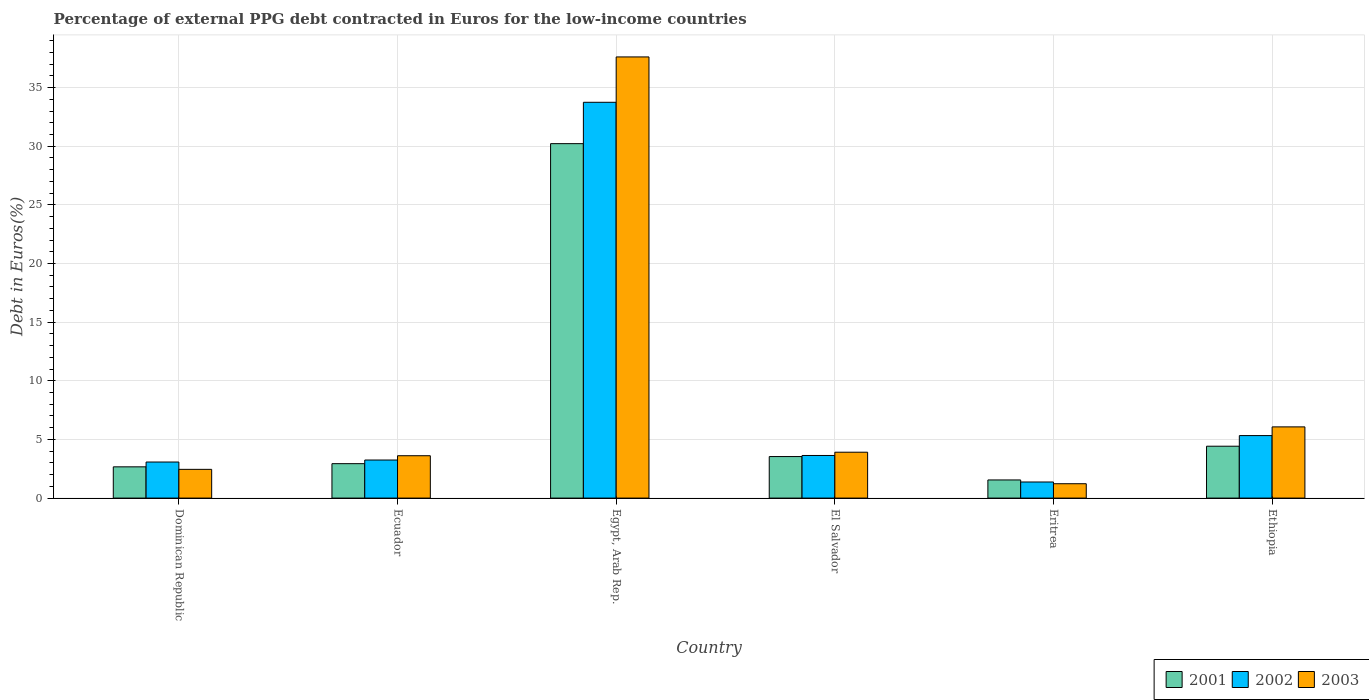How many different coloured bars are there?
Keep it short and to the point. 3. How many groups of bars are there?
Offer a very short reply. 6. Are the number of bars on each tick of the X-axis equal?
Give a very brief answer. Yes. What is the label of the 5th group of bars from the left?
Your answer should be very brief. Eritrea. In how many cases, is the number of bars for a given country not equal to the number of legend labels?
Your answer should be very brief. 0. What is the percentage of external PPG debt contracted in Euros in 2003 in Eritrea?
Your response must be concise. 1.23. Across all countries, what is the maximum percentage of external PPG debt contracted in Euros in 2003?
Ensure brevity in your answer.  37.61. Across all countries, what is the minimum percentage of external PPG debt contracted in Euros in 2003?
Your answer should be very brief. 1.23. In which country was the percentage of external PPG debt contracted in Euros in 2002 maximum?
Your answer should be very brief. Egypt, Arab Rep. In which country was the percentage of external PPG debt contracted in Euros in 2001 minimum?
Give a very brief answer. Eritrea. What is the total percentage of external PPG debt contracted in Euros in 2001 in the graph?
Ensure brevity in your answer.  45.33. What is the difference between the percentage of external PPG debt contracted in Euros in 2003 in Egypt, Arab Rep. and that in Eritrea?
Your answer should be compact. 36.39. What is the difference between the percentage of external PPG debt contracted in Euros in 2001 in Ethiopia and the percentage of external PPG debt contracted in Euros in 2003 in Egypt, Arab Rep.?
Offer a terse response. -33.19. What is the average percentage of external PPG debt contracted in Euros in 2002 per country?
Ensure brevity in your answer.  8.4. What is the difference between the percentage of external PPG debt contracted in Euros of/in 2001 and percentage of external PPG debt contracted in Euros of/in 2003 in Ethiopia?
Keep it short and to the point. -1.65. In how many countries, is the percentage of external PPG debt contracted in Euros in 2001 greater than 15 %?
Make the answer very short. 1. What is the ratio of the percentage of external PPG debt contracted in Euros in 2003 in Dominican Republic to that in Ecuador?
Give a very brief answer. 0.68. Is the percentage of external PPG debt contracted in Euros in 2002 in Dominican Republic less than that in Eritrea?
Your answer should be compact. No. What is the difference between the highest and the second highest percentage of external PPG debt contracted in Euros in 2002?
Give a very brief answer. 30.11. What is the difference between the highest and the lowest percentage of external PPG debt contracted in Euros in 2003?
Your response must be concise. 36.39. What does the 2nd bar from the left in Ecuador represents?
Keep it short and to the point. 2002. Are all the bars in the graph horizontal?
Provide a short and direct response. No. How many countries are there in the graph?
Provide a short and direct response. 6. What is the difference between two consecutive major ticks on the Y-axis?
Offer a very short reply. 5. Does the graph contain grids?
Keep it short and to the point. Yes. How are the legend labels stacked?
Offer a very short reply. Horizontal. What is the title of the graph?
Your response must be concise. Percentage of external PPG debt contracted in Euros for the low-income countries. Does "1968" appear as one of the legend labels in the graph?
Your answer should be compact. No. What is the label or title of the Y-axis?
Provide a succinct answer. Debt in Euros(%). What is the Debt in Euros(%) of 2001 in Dominican Republic?
Make the answer very short. 2.67. What is the Debt in Euros(%) in 2002 in Dominican Republic?
Provide a short and direct response. 3.08. What is the Debt in Euros(%) of 2003 in Dominican Republic?
Make the answer very short. 2.45. What is the Debt in Euros(%) in 2001 in Ecuador?
Your answer should be compact. 2.94. What is the Debt in Euros(%) of 2002 in Ecuador?
Offer a terse response. 3.25. What is the Debt in Euros(%) in 2003 in Ecuador?
Ensure brevity in your answer.  3.61. What is the Debt in Euros(%) of 2001 in Egypt, Arab Rep.?
Provide a succinct answer. 30.22. What is the Debt in Euros(%) of 2002 in Egypt, Arab Rep.?
Your answer should be compact. 33.75. What is the Debt in Euros(%) in 2003 in Egypt, Arab Rep.?
Provide a short and direct response. 37.61. What is the Debt in Euros(%) of 2001 in El Salvador?
Your answer should be compact. 3.54. What is the Debt in Euros(%) in 2002 in El Salvador?
Offer a very short reply. 3.63. What is the Debt in Euros(%) in 2003 in El Salvador?
Your answer should be very brief. 3.91. What is the Debt in Euros(%) in 2001 in Eritrea?
Offer a very short reply. 1.55. What is the Debt in Euros(%) in 2002 in Eritrea?
Make the answer very short. 1.37. What is the Debt in Euros(%) of 2003 in Eritrea?
Ensure brevity in your answer.  1.23. What is the Debt in Euros(%) of 2001 in Ethiopia?
Provide a short and direct response. 4.42. What is the Debt in Euros(%) of 2002 in Ethiopia?
Make the answer very short. 5.33. What is the Debt in Euros(%) in 2003 in Ethiopia?
Provide a succinct answer. 6.07. Across all countries, what is the maximum Debt in Euros(%) in 2001?
Ensure brevity in your answer.  30.22. Across all countries, what is the maximum Debt in Euros(%) in 2002?
Give a very brief answer. 33.75. Across all countries, what is the maximum Debt in Euros(%) of 2003?
Provide a succinct answer. 37.61. Across all countries, what is the minimum Debt in Euros(%) in 2001?
Provide a short and direct response. 1.55. Across all countries, what is the minimum Debt in Euros(%) in 2002?
Ensure brevity in your answer.  1.37. Across all countries, what is the minimum Debt in Euros(%) of 2003?
Provide a succinct answer. 1.23. What is the total Debt in Euros(%) in 2001 in the graph?
Keep it short and to the point. 45.33. What is the total Debt in Euros(%) in 2002 in the graph?
Ensure brevity in your answer.  50.4. What is the total Debt in Euros(%) in 2003 in the graph?
Your answer should be very brief. 54.88. What is the difference between the Debt in Euros(%) in 2001 in Dominican Republic and that in Ecuador?
Make the answer very short. -0.27. What is the difference between the Debt in Euros(%) of 2002 in Dominican Republic and that in Ecuador?
Give a very brief answer. -0.17. What is the difference between the Debt in Euros(%) of 2003 in Dominican Republic and that in Ecuador?
Provide a succinct answer. -1.16. What is the difference between the Debt in Euros(%) of 2001 in Dominican Republic and that in Egypt, Arab Rep.?
Your response must be concise. -27.55. What is the difference between the Debt in Euros(%) in 2002 in Dominican Republic and that in Egypt, Arab Rep.?
Make the answer very short. -30.67. What is the difference between the Debt in Euros(%) in 2003 in Dominican Republic and that in Egypt, Arab Rep.?
Your response must be concise. -35.16. What is the difference between the Debt in Euros(%) of 2001 in Dominican Republic and that in El Salvador?
Offer a terse response. -0.88. What is the difference between the Debt in Euros(%) of 2002 in Dominican Republic and that in El Salvador?
Offer a terse response. -0.56. What is the difference between the Debt in Euros(%) in 2003 in Dominican Republic and that in El Salvador?
Offer a very short reply. -1.46. What is the difference between the Debt in Euros(%) in 2001 in Dominican Republic and that in Eritrea?
Make the answer very short. 1.12. What is the difference between the Debt in Euros(%) in 2002 in Dominican Republic and that in Eritrea?
Offer a very short reply. 1.7. What is the difference between the Debt in Euros(%) in 2003 in Dominican Republic and that in Eritrea?
Offer a terse response. 1.23. What is the difference between the Debt in Euros(%) in 2001 in Dominican Republic and that in Ethiopia?
Keep it short and to the point. -1.76. What is the difference between the Debt in Euros(%) of 2002 in Dominican Republic and that in Ethiopia?
Give a very brief answer. -2.25. What is the difference between the Debt in Euros(%) of 2003 in Dominican Republic and that in Ethiopia?
Keep it short and to the point. -3.62. What is the difference between the Debt in Euros(%) of 2001 in Ecuador and that in Egypt, Arab Rep.?
Your answer should be compact. -27.28. What is the difference between the Debt in Euros(%) of 2002 in Ecuador and that in Egypt, Arab Rep.?
Offer a terse response. -30.5. What is the difference between the Debt in Euros(%) in 2003 in Ecuador and that in Egypt, Arab Rep.?
Offer a very short reply. -34. What is the difference between the Debt in Euros(%) in 2001 in Ecuador and that in El Salvador?
Make the answer very short. -0.61. What is the difference between the Debt in Euros(%) in 2002 in Ecuador and that in El Salvador?
Offer a terse response. -0.39. What is the difference between the Debt in Euros(%) in 2003 in Ecuador and that in El Salvador?
Provide a short and direct response. -0.3. What is the difference between the Debt in Euros(%) in 2001 in Ecuador and that in Eritrea?
Provide a short and direct response. 1.39. What is the difference between the Debt in Euros(%) in 2002 in Ecuador and that in Eritrea?
Your answer should be very brief. 1.87. What is the difference between the Debt in Euros(%) of 2003 in Ecuador and that in Eritrea?
Provide a succinct answer. 2.39. What is the difference between the Debt in Euros(%) of 2001 in Ecuador and that in Ethiopia?
Provide a short and direct response. -1.49. What is the difference between the Debt in Euros(%) in 2002 in Ecuador and that in Ethiopia?
Provide a succinct answer. -2.08. What is the difference between the Debt in Euros(%) in 2003 in Ecuador and that in Ethiopia?
Your response must be concise. -2.46. What is the difference between the Debt in Euros(%) of 2001 in Egypt, Arab Rep. and that in El Salvador?
Provide a succinct answer. 26.68. What is the difference between the Debt in Euros(%) of 2002 in Egypt, Arab Rep. and that in El Salvador?
Give a very brief answer. 30.11. What is the difference between the Debt in Euros(%) of 2003 in Egypt, Arab Rep. and that in El Salvador?
Ensure brevity in your answer.  33.7. What is the difference between the Debt in Euros(%) of 2001 in Egypt, Arab Rep. and that in Eritrea?
Offer a terse response. 28.67. What is the difference between the Debt in Euros(%) of 2002 in Egypt, Arab Rep. and that in Eritrea?
Provide a succinct answer. 32.37. What is the difference between the Debt in Euros(%) in 2003 in Egypt, Arab Rep. and that in Eritrea?
Your response must be concise. 36.39. What is the difference between the Debt in Euros(%) in 2001 in Egypt, Arab Rep. and that in Ethiopia?
Make the answer very short. 25.8. What is the difference between the Debt in Euros(%) of 2002 in Egypt, Arab Rep. and that in Ethiopia?
Ensure brevity in your answer.  28.42. What is the difference between the Debt in Euros(%) of 2003 in Egypt, Arab Rep. and that in Ethiopia?
Your answer should be very brief. 31.54. What is the difference between the Debt in Euros(%) in 2001 in El Salvador and that in Eritrea?
Keep it short and to the point. 1.99. What is the difference between the Debt in Euros(%) of 2002 in El Salvador and that in Eritrea?
Provide a succinct answer. 2.26. What is the difference between the Debt in Euros(%) in 2003 in El Salvador and that in Eritrea?
Give a very brief answer. 2.69. What is the difference between the Debt in Euros(%) of 2001 in El Salvador and that in Ethiopia?
Provide a short and direct response. -0.88. What is the difference between the Debt in Euros(%) in 2002 in El Salvador and that in Ethiopia?
Keep it short and to the point. -1.7. What is the difference between the Debt in Euros(%) in 2003 in El Salvador and that in Ethiopia?
Your answer should be very brief. -2.16. What is the difference between the Debt in Euros(%) in 2001 in Eritrea and that in Ethiopia?
Offer a terse response. -2.88. What is the difference between the Debt in Euros(%) of 2002 in Eritrea and that in Ethiopia?
Offer a very short reply. -3.96. What is the difference between the Debt in Euros(%) in 2003 in Eritrea and that in Ethiopia?
Give a very brief answer. -4.85. What is the difference between the Debt in Euros(%) of 2001 in Dominican Republic and the Debt in Euros(%) of 2002 in Ecuador?
Provide a short and direct response. -0.58. What is the difference between the Debt in Euros(%) in 2001 in Dominican Republic and the Debt in Euros(%) in 2003 in Ecuador?
Offer a terse response. -0.95. What is the difference between the Debt in Euros(%) of 2002 in Dominican Republic and the Debt in Euros(%) of 2003 in Ecuador?
Your answer should be compact. -0.54. What is the difference between the Debt in Euros(%) in 2001 in Dominican Republic and the Debt in Euros(%) in 2002 in Egypt, Arab Rep.?
Provide a succinct answer. -31.08. What is the difference between the Debt in Euros(%) in 2001 in Dominican Republic and the Debt in Euros(%) in 2003 in Egypt, Arab Rep.?
Offer a very short reply. -34.95. What is the difference between the Debt in Euros(%) of 2002 in Dominican Republic and the Debt in Euros(%) of 2003 in Egypt, Arab Rep.?
Give a very brief answer. -34.54. What is the difference between the Debt in Euros(%) in 2001 in Dominican Republic and the Debt in Euros(%) in 2002 in El Salvador?
Offer a terse response. -0.97. What is the difference between the Debt in Euros(%) in 2001 in Dominican Republic and the Debt in Euros(%) in 2003 in El Salvador?
Your answer should be compact. -1.25. What is the difference between the Debt in Euros(%) in 2002 in Dominican Republic and the Debt in Euros(%) in 2003 in El Salvador?
Offer a terse response. -0.84. What is the difference between the Debt in Euros(%) in 2001 in Dominican Republic and the Debt in Euros(%) in 2002 in Eritrea?
Make the answer very short. 1.29. What is the difference between the Debt in Euros(%) in 2001 in Dominican Republic and the Debt in Euros(%) in 2003 in Eritrea?
Make the answer very short. 1.44. What is the difference between the Debt in Euros(%) in 2002 in Dominican Republic and the Debt in Euros(%) in 2003 in Eritrea?
Keep it short and to the point. 1.85. What is the difference between the Debt in Euros(%) in 2001 in Dominican Republic and the Debt in Euros(%) in 2002 in Ethiopia?
Provide a succinct answer. -2.66. What is the difference between the Debt in Euros(%) of 2001 in Dominican Republic and the Debt in Euros(%) of 2003 in Ethiopia?
Offer a very short reply. -3.41. What is the difference between the Debt in Euros(%) in 2002 in Dominican Republic and the Debt in Euros(%) in 2003 in Ethiopia?
Your response must be concise. -3. What is the difference between the Debt in Euros(%) of 2001 in Ecuador and the Debt in Euros(%) of 2002 in Egypt, Arab Rep.?
Your answer should be compact. -30.81. What is the difference between the Debt in Euros(%) of 2001 in Ecuador and the Debt in Euros(%) of 2003 in Egypt, Arab Rep.?
Your answer should be compact. -34.68. What is the difference between the Debt in Euros(%) of 2002 in Ecuador and the Debt in Euros(%) of 2003 in Egypt, Arab Rep.?
Give a very brief answer. -34.37. What is the difference between the Debt in Euros(%) of 2001 in Ecuador and the Debt in Euros(%) of 2002 in El Salvador?
Make the answer very short. -0.7. What is the difference between the Debt in Euros(%) of 2001 in Ecuador and the Debt in Euros(%) of 2003 in El Salvador?
Ensure brevity in your answer.  -0.98. What is the difference between the Debt in Euros(%) of 2002 in Ecuador and the Debt in Euros(%) of 2003 in El Salvador?
Offer a very short reply. -0.67. What is the difference between the Debt in Euros(%) of 2001 in Ecuador and the Debt in Euros(%) of 2002 in Eritrea?
Keep it short and to the point. 1.56. What is the difference between the Debt in Euros(%) of 2001 in Ecuador and the Debt in Euros(%) of 2003 in Eritrea?
Keep it short and to the point. 1.71. What is the difference between the Debt in Euros(%) in 2002 in Ecuador and the Debt in Euros(%) in 2003 in Eritrea?
Ensure brevity in your answer.  2.02. What is the difference between the Debt in Euros(%) in 2001 in Ecuador and the Debt in Euros(%) in 2002 in Ethiopia?
Keep it short and to the point. -2.39. What is the difference between the Debt in Euros(%) of 2001 in Ecuador and the Debt in Euros(%) of 2003 in Ethiopia?
Keep it short and to the point. -3.14. What is the difference between the Debt in Euros(%) in 2002 in Ecuador and the Debt in Euros(%) in 2003 in Ethiopia?
Your response must be concise. -2.83. What is the difference between the Debt in Euros(%) in 2001 in Egypt, Arab Rep. and the Debt in Euros(%) in 2002 in El Salvador?
Offer a terse response. 26.59. What is the difference between the Debt in Euros(%) in 2001 in Egypt, Arab Rep. and the Debt in Euros(%) in 2003 in El Salvador?
Offer a terse response. 26.31. What is the difference between the Debt in Euros(%) in 2002 in Egypt, Arab Rep. and the Debt in Euros(%) in 2003 in El Salvador?
Keep it short and to the point. 29.83. What is the difference between the Debt in Euros(%) of 2001 in Egypt, Arab Rep. and the Debt in Euros(%) of 2002 in Eritrea?
Ensure brevity in your answer.  28.85. What is the difference between the Debt in Euros(%) in 2001 in Egypt, Arab Rep. and the Debt in Euros(%) in 2003 in Eritrea?
Your answer should be compact. 29. What is the difference between the Debt in Euros(%) in 2002 in Egypt, Arab Rep. and the Debt in Euros(%) in 2003 in Eritrea?
Your answer should be compact. 32.52. What is the difference between the Debt in Euros(%) in 2001 in Egypt, Arab Rep. and the Debt in Euros(%) in 2002 in Ethiopia?
Provide a short and direct response. 24.89. What is the difference between the Debt in Euros(%) in 2001 in Egypt, Arab Rep. and the Debt in Euros(%) in 2003 in Ethiopia?
Keep it short and to the point. 24.15. What is the difference between the Debt in Euros(%) of 2002 in Egypt, Arab Rep. and the Debt in Euros(%) of 2003 in Ethiopia?
Make the answer very short. 27.68. What is the difference between the Debt in Euros(%) in 2001 in El Salvador and the Debt in Euros(%) in 2002 in Eritrea?
Provide a succinct answer. 2.17. What is the difference between the Debt in Euros(%) of 2001 in El Salvador and the Debt in Euros(%) of 2003 in Eritrea?
Provide a succinct answer. 2.32. What is the difference between the Debt in Euros(%) in 2002 in El Salvador and the Debt in Euros(%) in 2003 in Eritrea?
Ensure brevity in your answer.  2.41. What is the difference between the Debt in Euros(%) of 2001 in El Salvador and the Debt in Euros(%) of 2002 in Ethiopia?
Your answer should be very brief. -1.79. What is the difference between the Debt in Euros(%) in 2001 in El Salvador and the Debt in Euros(%) in 2003 in Ethiopia?
Your response must be concise. -2.53. What is the difference between the Debt in Euros(%) in 2002 in El Salvador and the Debt in Euros(%) in 2003 in Ethiopia?
Your answer should be compact. -2.44. What is the difference between the Debt in Euros(%) in 2001 in Eritrea and the Debt in Euros(%) in 2002 in Ethiopia?
Make the answer very short. -3.78. What is the difference between the Debt in Euros(%) of 2001 in Eritrea and the Debt in Euros(%) of 2003 in Ethiopia?
Your answer should be very brief. -4.52. What is the difference between the Debt in Euros(%) in 2002 in Eritrea and the Debt in Euros(%) in 2003 in Ethiopia?
Your answer should be very brief. -4.7. What is the average Debt in Euros(%) of 2001 per country?
Offer a very short reply. 7.56. What is the average Debt in Euros(%) in 2002 per country?
Offer a very short reply. 8.4. What is the average Debt in Euros(%) of 2003 per country?
Provide a succinct answer. 9.15. What is the difference between the Debt in Euros(%) of 2001 and Debt in Euros(%) of 2002 in Dominican Republic?
Give a very brief answer. -0.41. What is the difference between the Debt in Euros(%) of 2001 and Debt in Euros(%) of 2003 in Dominican Republic?
Give a very brief answer. 0.22. What is the difference between the Debt in Euros(%) of 2001 and Debt in Euros(%) of 2002 in Ecuador?
Keep it short and to the point. -0.31. What is the difference between the Debt in Euros(%) of 2001 and Debt in Euros(%) of 2003 in Ecuador?
Your answer should be very brief. -0.68. What is the difference between the Debt in Euros(%) of 2002 and Debt in Euros(%) of 2003 in Ecuador?
Your response must be concise. -0.37. What is the difference between the Debt in Euros(%) of 2001 and Debt in Euros(%) of 2002 in Egypt, Arab Rep.?
Give a very brief answer. -3.53. What is the difference between the Debt in Euros(%) of 2001 and Debt in Euros(%) of 2003 in Egypt, Arab Rep.?
Keep it short and to the point. -7.39. What is the difference between the Debt in Euros(%) in 2002 and Debt in Euros(%) in 2003 in Egypt, Arab Rep.?
Give a very brief answer. -3.87. What is the difference between the Debt in Euros(%) of 2001 and Debt in Euros(%) of 2002 in El Salvador?
Provide a short and direct response. -0.09. What is the difference between the Debt in Euros(%) of 2001 and Debt in Euros(%) of 2003 in El Salvador?
Offer a terse response. -0.37. What is the difference between the Debt in Euros(%) in 2002 and Debt in Euros(%) in 2003 in El Salvador?
Give a very brief answer. -0.28. What is the difference between the Debt in Euros(%) of 2001 and Debt in Euros(%) of 2002 in Eritrea?
Your answer should be compact. 0.18. What is the difference between the Debt in Euros(%) in 2001 and Debt in Euros(%) in 2003 in Eritrea?
Give a very brief answer. 0.32. What is the difference between the Debt in Euros(%) of 2002 and Debt in Euros(%) of 2003 in Eritrea?
Keep it short and to the point. 0.15. What is the difference between the Debt in Euros(%) in 2001 and Debt in Euros(%) in 2002 in Ethiopia?
Your answer should be compact. -0.91. What is the difference between the Debt in Euros(%) in 2001 and Debt in Euros(%) in 2003 in Ethiopia?
Provide a short and direct response. -1.65. What is the difference between the Debt in Euros(%) of 2002 and Debt in Euros(%) of 2003 in Ethiopia?
Offer a very short reply. -0.74. What is the ratio of the Debt in Euros(%) of 2001 in Dominican Republic to that in Ecuador?
Offer a terse response. 0.91. What is the ratio of the Debt in Euros(%) in 2002 in Dominican Republic to that in Ecuador?
Provide a short and direct response. 0.95. What is the ratio of the Debt in Euros(%) of 2003 in Dominican Republic to that in Ecuador?
Your response must be concise. 0.68. What is the ratio of the Debt in Euros(%) in 2001 in Dominican Republic to that in Egypt, Arab Rep.?
Ensure brevity in your answer.  0.09. What is the ratio of the Debt in Euros(%) in 2002 in Dominican Republic to that in Egypt, Arab Rep.?
Make the answer very short. 0.09. What is the ratio of the Debt in Euros(%) in 2003 in Dominican Republic to that in Egypt, Arab Rep.?
Make the answer very short. 0.07. What is the ratio of the Debt in Euros(%) of 2001 in Dominican Republic to that in El Salvador?
Make the answer very short. 0.75. What is the ratio of the Debt in Euros(%) of 2002 in Dominican Republic to that in El Salvador?
Keep it short and to the point. 0.85. What is the ratio of the Debt in Euros(%) of 2003 in Dominican Republic to that in El Salvador?
Provide a succinct answer. 0.63. What is the ratio of the Debt in Euros(%) in 2001 in Dominican Republic to that in Eritrea?
Your answer should be compact. 1.72. What is the ratio of the Debt in Euros(%) in 2002 in Dominican Republic to that in Eritrea?
Make the answer very short. 2.24. What is the ratio of the Debt in Euros(%) of 2003 in Dominican Republic to that in Eritrea?
Make the answer very short. 2. What is the ratio of the Debt in Euros(%) in 2001 in Dominican Republic to that in Ethiopia?
Give a very brief answer. 0.6. What is the ratio of the Debt in Euros(%) of 2002 in Dominican Republic to that in Ethiopia?
Offer a very short reply. 0.58. What is the ratio of the Debt in Euros(%) in 2003 in Dominican Republic to that in Ethiopia?
Your answer should be very brief. 0.4. What is the ratio of the Debt in Euros(%) in 2001 in Ecuador to that in Egypt, Arab Rep.?
Make the answer very short. 0.1. What is the ratio of the Debt in Euros(%) in 2002 in Ecuador to that in Egypt, Arab Rep.?
Keep it short and to the point. 0.1. What is the ratio of the Debt in Euros(%) in 2003 in Ecuador to that in Egypt, Arab Rep.?
Offer a terse response. 0.1. What is the ratio of the Debt in Euros(%) of 2001 in Ecuador to that in El Salvador?
Make the answer very short. 0.83. What is the ratio of the Debt in Euros(%) in 2002 in Ecuador to that in El Salvador?
Your response must be concise. 0.89. What is the ratio of the Debt in Euros(%) in 2003 in Ecuador to that in El Salvador?
Keep it short and to the point. 0.92. What is the ratio of the Debt in Euros(%) of 2001 in Ecuador to that in Eritrea?
Make the answer very short. 1.9. What is the ratio of the Debt in Euros(%) in 2002 in Ecuador to that in Eritrea?
Your answer should be very brief. 2.37. What is the ratio of the Debt in Euros(%) in 2003 in Ecuador to that in Eritrea?
Give a very brief answer. 2.95. What is the ratio of the Debt in Euros(%) of 2001 in Ecuador to that in Ethiopia?
Offer a very short reply. 0.66. What is the ratio of the Debt in Euros(%) in 2002 in Ecuador to that in Ethiopia?
Your response must be concise. 0.61. What is the ratio of the Debt in Euros(%) of 2003 in Ecuador to that in Ethiopia?
Provide a short and direct response. 0.59. What is the ratio of the Debt in Euros(%) of 2001 in Egypt, Arab Rep. to that in El Salvador?
Ensure brevity in your answer.  8.53. What is the ratio of the Debt in Euros(%) of 2002 in Egypt, Arab Rep. to that in El Salvador?
Ensure brevity in your answer.  9.29. What is the ratio of the Debt in Euros(%) of 2003 in Egypt, Arab Rep. to that in El Salvador?
Keep it short and to the point. 9.62. What is the ratio of the Debt in Euros(%) of 2001 in Egypt, Arab Rep. to that in Eritrea?
Your answer should be very brief. 19.53. What is the ratio of the Debt in Euros(%) in 2002 in Egypt, Arab Rep. to that in Eritrea?
Give a very brief answer. 24.59. What is the ratio of the Debt in Euros(%) of 2003 in Egypt, Arab Rep. to that in Eritrea?
Provide a succinct answer. 30.71. What is the ratio of the Debt in Euros(%) of 2001 in Egypt, Arab Rep. to that in Ethiopia?
Your response must be concise. 6.83. What is the ratio of the Debt in Euros(%) in 2002 in Egypt, Arab Rep. to that in Ethiopia?
Provide a short and direct response. 6.33. What is the ratio of the Debt in Euros(%) in 2003 in Egypt, Arab Rep. to that in Ethiopia?
Ensure brevity in your answer.  6.2. What is the ratio of the Debt in Euros(%) of 2001 in El Salvador to that in Eritrea?
Provide a succinct answer. 2.29. What is the ratio of the Debt in Euros(%) in 2002 in El Salvador to that in Eritrea?
Provide a succinct answer. 2.65. What is the ratio of the Debt in Euros(%) in 2003 in El Salvador to that in Eritrea?
Provide a short and direct response. 3.19. What is the ratio of the Debt in Euros(%) of 2001 in El Salvador to that in Ethiopia?
Provide a short and direct response. 0.8. What is the ratio of the Debt in Euros(%) in 2002 in El Salvador to that in Ethiopia?
Your response must be concise. 0.68. What is the ratio of the Debt in Euros(%) of 2003 in El Salvador to that in Ethiopia?
Offer a very short reply. 0.64. What is the ratio of the Debt in Euros(%) of 2001 in Eritrea to that in Ethiopia?
Provide a short and direct response. 0.35. What is the ratio of the Debt in Euros(%) of 2002 in Eritrea to that in Ethiopia?
Ensure brevity in your answer.  0.26. What is the ratio of the Debt in Euros(%) of 2003 in Eritrea to that in Ethiopia?
Your answer should be very brief. 0.2. What is the difference between the highest and the second highest Debt in Euros(%) in 2001?
Offer a terse response. 25.8. What is the difference between the highest and the second highest Debt in Euros(%) in 2002?
Offer a very short reply. 28.42. What is the difference between the highest and the second highest Debt in Euros(%) of 2003?
Keep it short and to the point. 31.54. What is the difference between the highest and the lowest Debt in Euros(%) of 2001?
Your answer should be very brief. 28.67. What is the difference between the highest and the lowest Debt in Euros(%) in 2002?
Provide a succinct answer. 32.37. What is the difference between the highest and the lowest Debt in Euros(%) of 2003?
Keep it short and to the point. 36.39. 